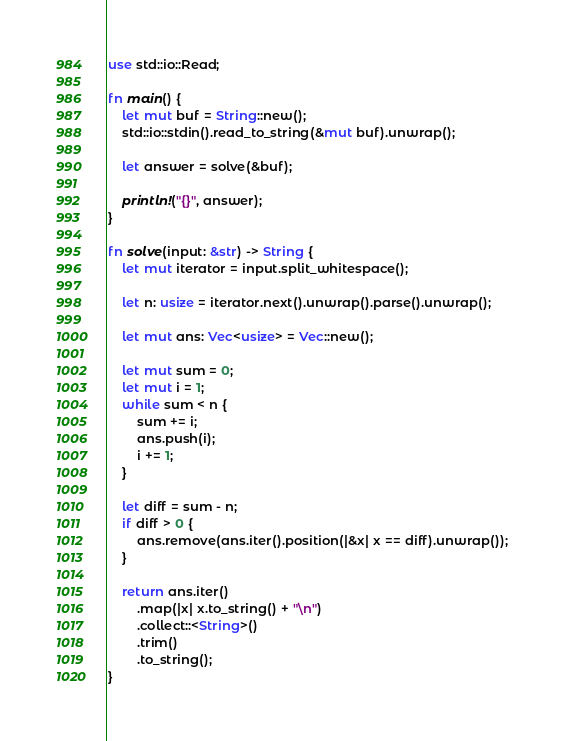<code> <loc_0><loc_0><loc_500><loc_500><_Rust_>use std::io::Read;

fn main() {
    let mut buf = String::new();
    std::io::stdin().read_to_string(&mut buf).unwrap();

    let answer = solve(&buf);

    println!("{}", answer);
}

fn solve(input: &str) -> String {
    let mut iterator = input.split_whitespace();

    let n: usize = iterator.next().unwrap().parse().unwrap();

    let mut ans: Vec<usize> = Vec::new();

    let mut sum = 0;
    let mut i = 1;
    while sum < n {
        sum += i;
        ans.push(i);
        i += 1;
    }

    let diff = sum - n;
    if diff > 0 {
        ans.remove(ans.iter().position(|&x| x == diff).unwrap());
    }

    return ans.iter()
        .map(|x| x.to_string() + "\n")
        .collect::<String>()
        .trim()
        .to_string();
}
</code> 